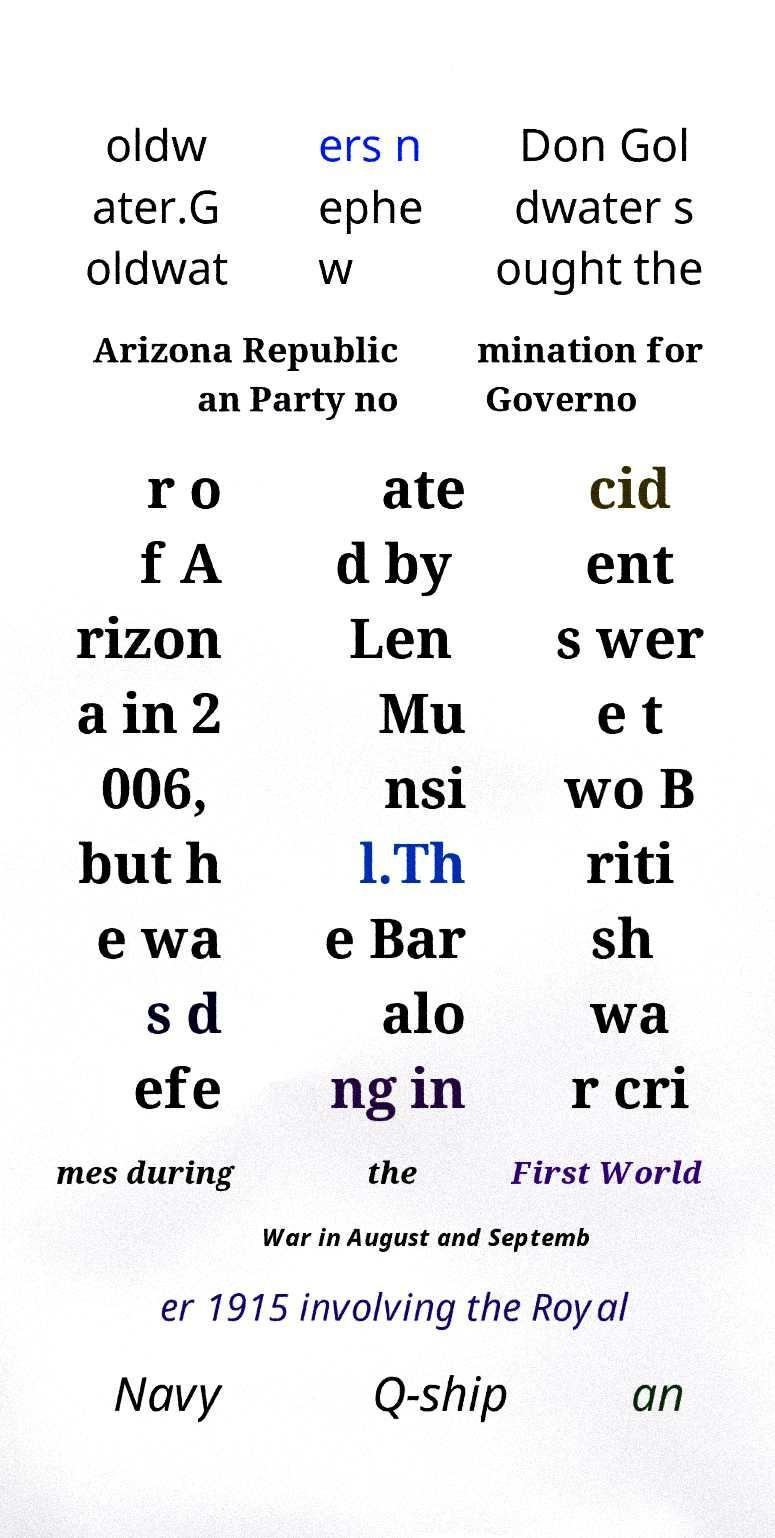Please read and relay the text visible in this image. What does it say? oldw ater.G oldwat ers n ephe w Don Gol dwater s ought the Arizona Republic an Party no mination for Governo r o f A rizon a in 2 006, but h e wa s d efe ate d by Len Mu nsi l.Th e Bar alo ng in cid ent s wer e t wo B riti sh wa r cri mes during the First World War in August and Septemb er 1915 involving the Royal Navy Q-ship an 